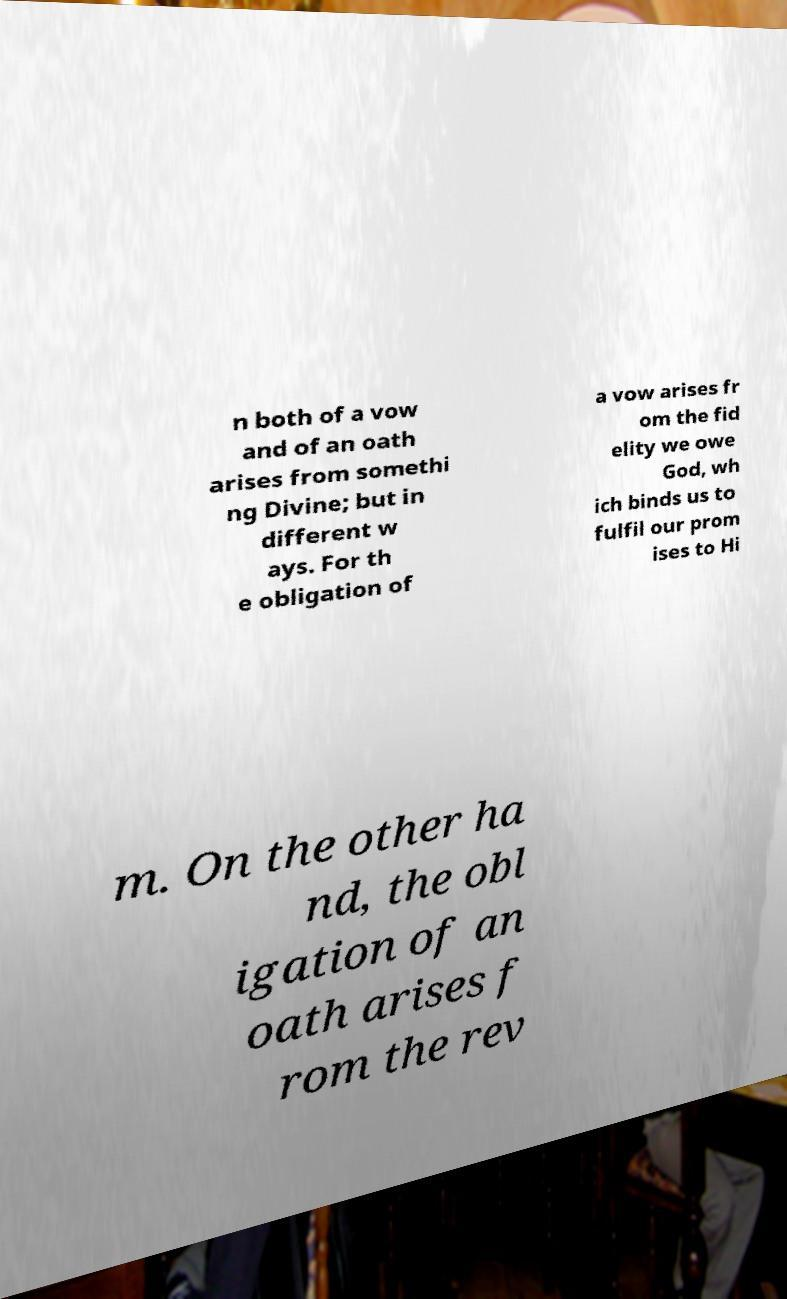There's text embedded in this image that I need extracted. Can you transcribe it verbatim? n both of a vow and of an oath arises from somethi ng Divine; but in different w ays. For th e obligation of a vow arises fr om the fid elity we owe God, wh ich binds us to fulfil our prom ises to Hi m. On the other ha nd, the obl igation of an oath arises f rom the rev 